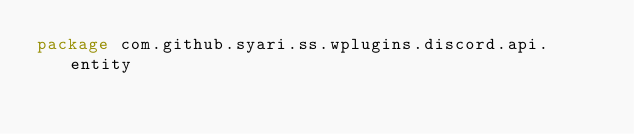<code> <loc_0><loc_0><loc_500><loc_500><_Kotlin_>package com.github.syari.ss.wplugins.discord.api.entity
</code> 